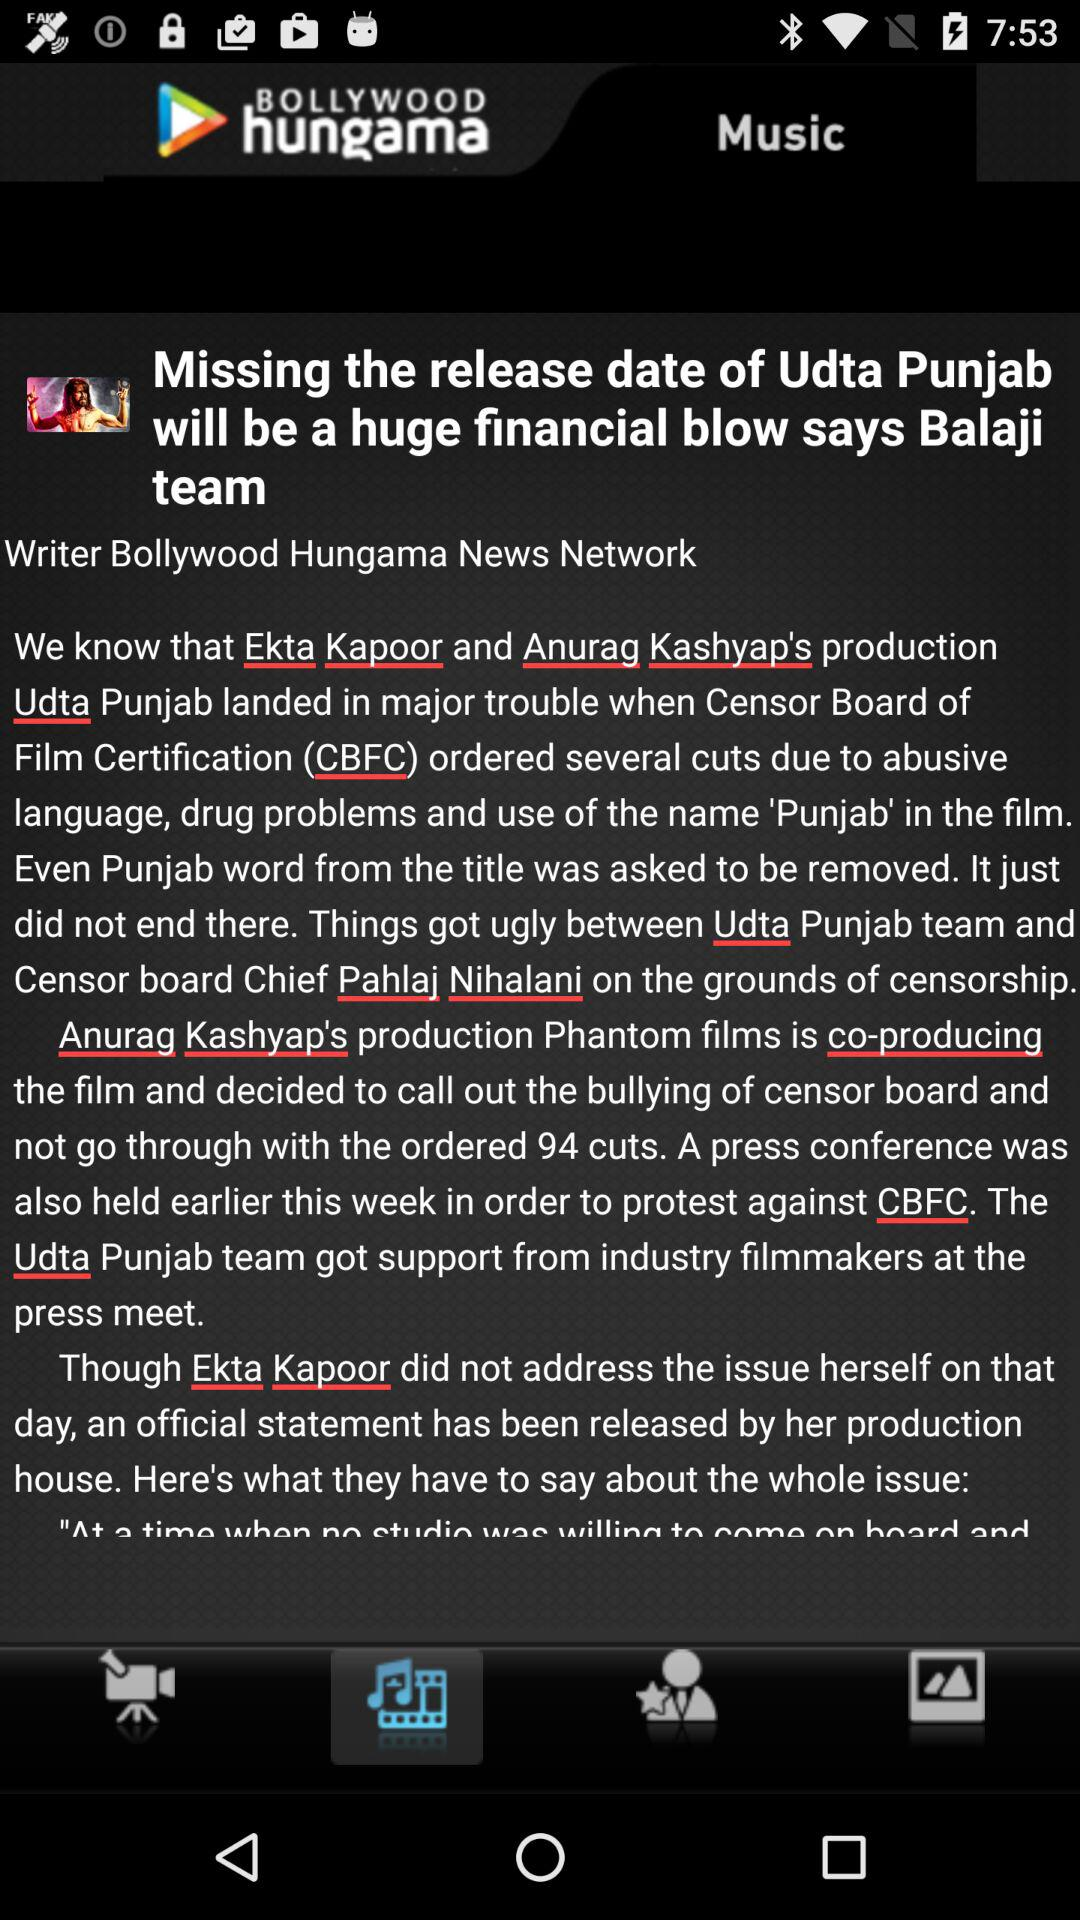What is the application name? The application name is "BOLLYWOOD hungama". 